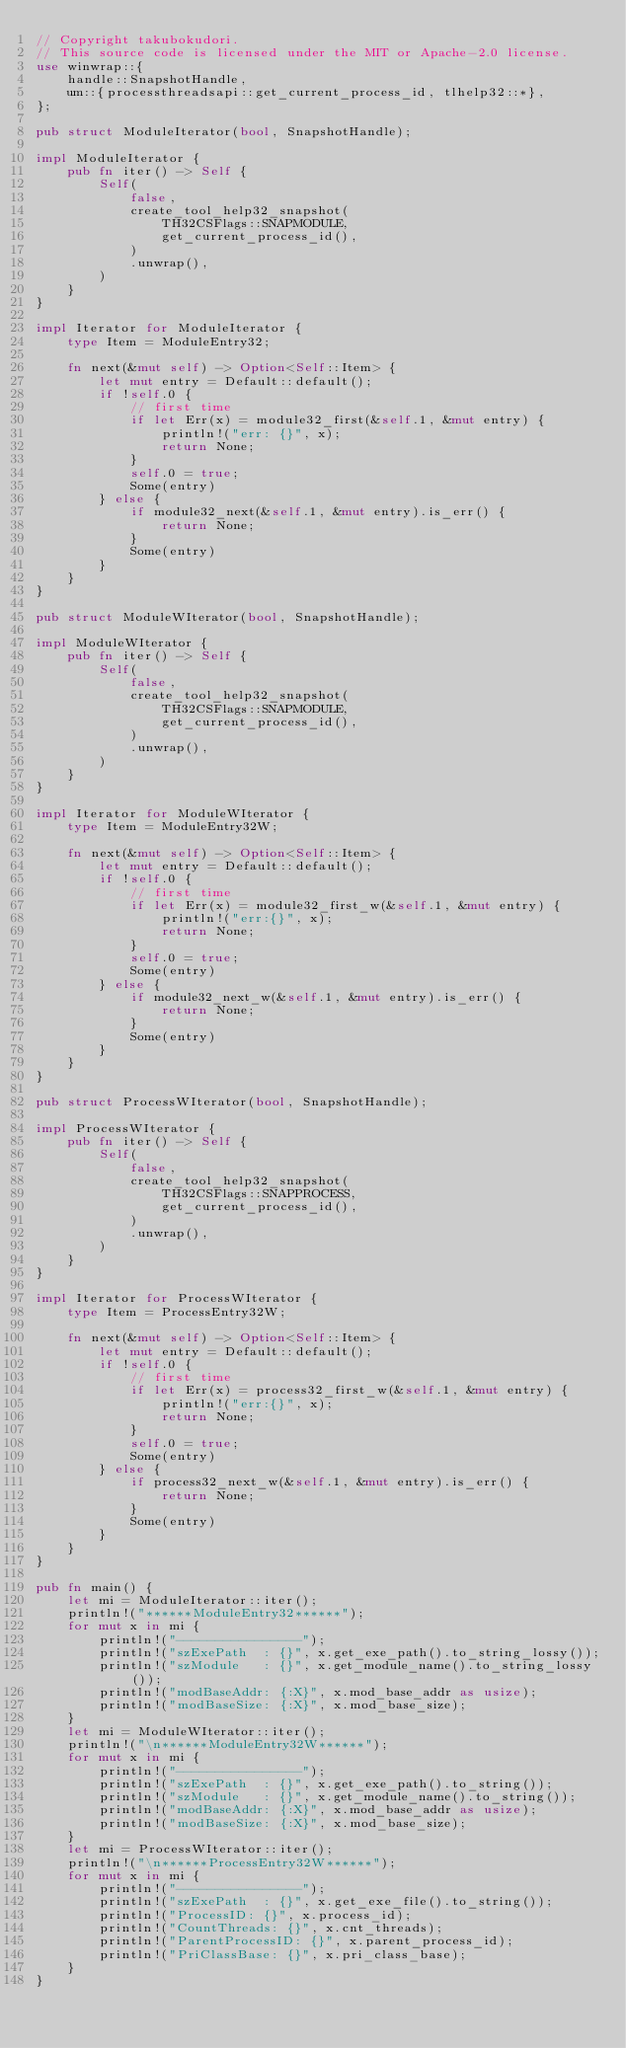Convert code to text. <code><loc_0><loc_0><loc_500><loc_500><_Rust_>// Copyright takubokudori.
// This source code is licensed under the MIT or Apache-2.0 license.
use winwrap::{
    handle::SnapshotHandle,
    um::{processthreadsapi::get_current_process_id, tlhelp32::*},
};

pub struct ModuleIterator(bool, SnapshotHandle);

impl ModuleIterator {
    pub fn iter() -> Self {
        Self(
            false,
            create_tool_help32_snapshot(
                TH32CSFlags::SNAPMODULE,
                get_current_process_id(),
            )
            .unwrap(),
        )
    }
}

impl Iterator for ModuleIterator {
    type Item = ModuleEntry32;

    fn next(&mut self) -> Option<Self::Item> {
        let mut entry = Default::default();
        if !self.0 {
            // first time
            if let Err(x) = module32_first(&self.1, &mut entry) {
                println!("err: {}", x);
                return None;
            }
            self.0 = true;
            Some(entry)
        } else {
            if module32_next(&self.1, &mut entry).is_err() {
                return None;
            }
            Some(entry)
        }
    }
}

pub struct ModuleWIterator(bool, SnapshotHandle);

impl ModuleWIterator {
    pub fn iter() -> Self {
        Self(
            false,
            create_tool_help32_snapshot(
                TH32CSFlags::SNAPMODULE,
                get_current_process_id(),
            )
            .unwrap(),
        )
    }
}

impl Iterator for ModuleWIterator {
    type Item = ModuleEntry32W;

    fn next(&mut self) -> Option<Self::Item> {
        let mut entry = Default::default();
        if !self.0 {
            // first time
            if let Err(x) = module32_first_w(&self.1, &mut entry) {
                println!("err:{}", x);
                return None;
            }
            self.0 = true;
            Some(entry)
        } else {
            if module32_next_w(&self.1, &mut entry).is_err() {
                return None;
            }
            Some(entry)
        }
    }
}

pub struct ProcessWIterator(bool, SnapshotHandle);

impl ProcessWIterator {
    pub fn iter() -> Self {
        Self(
            false,
            create_tool_help32_snapshot(
                TH32CSFlags::SNAPPROCESS,
                get_current_process_id(),
            )
            .unwrap(),
        )
    }
}

impl Iterator for ProcessWIterator {
    type Item = ProcessEntry32W;

    fn next(&mut self) -> Option<Self::Item> {
        let mut entry = Default::default();
        if !self.0 {
            // first time
            if let Err(x) = process32_first_w(&self.1, &mut entry) {
                println!("err:{}", x);
                return None;
            }
            self.0 = true;
            Some(entry)
        } else {
            if process32_next_w(&self.1, &mut entry).is_err() {
                return None;
            }
            Some(entry)
        }
    }
}

pub fn main() {
    let mi = ModuleIterator::iter();
    println!("******ModuleEntry32******");
    for mut x in mi {
        println!("----------------");
        println!("szExePath  : {}", x.get_exe_path().to_string_lossy());
        println!("szModule   : {}", x.get_module_name().to_string_lossy());
        println!("modBaseAddr: {:X}", x.mod_base_addr as usize);
        println!("modBaseSize: {:X}", x.mod_base_size);
    }
    let mi = ModuleWIterator::iter();
    println!("\n******ModuleEntry32W******");
    for mut x in mi {
        println!("----------------");
        println!("szExePath  : {}", x.get_exe_path().to_string());
        println!("szModule   : {}", x.get_module_name().to_string());
        println!("modBaseAddr: {:X}", x.mod_base_addr as usize);
        println!("modBaseSize: {:X}", x.mod_base_size);
    }
    let mi = ProcessWIterator::iter();
    println!("\n******ProcessEntry32W******");
    for mut x in mi {
        println!("----------------");
        println!("szExePath  : {}", x.get_exe_file().to_string());
        println!("ProcessID: {}", x.process_id);
        println!("CountThreads: {}", x.cnt_threads);
        println!("ParentProcessID: {}", x.parent_process_id);
        println!("PriClassBase: {}", x.pri_class_base);
    }
}
</code> 